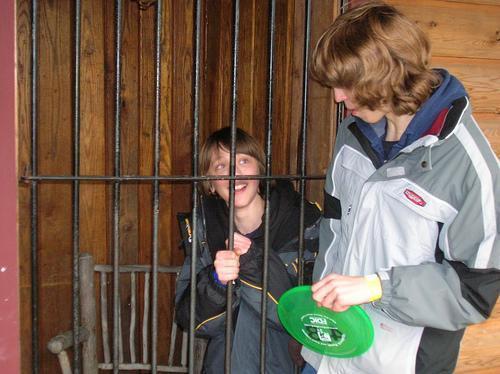How many people are there?
Give a very brief answer. 2. 